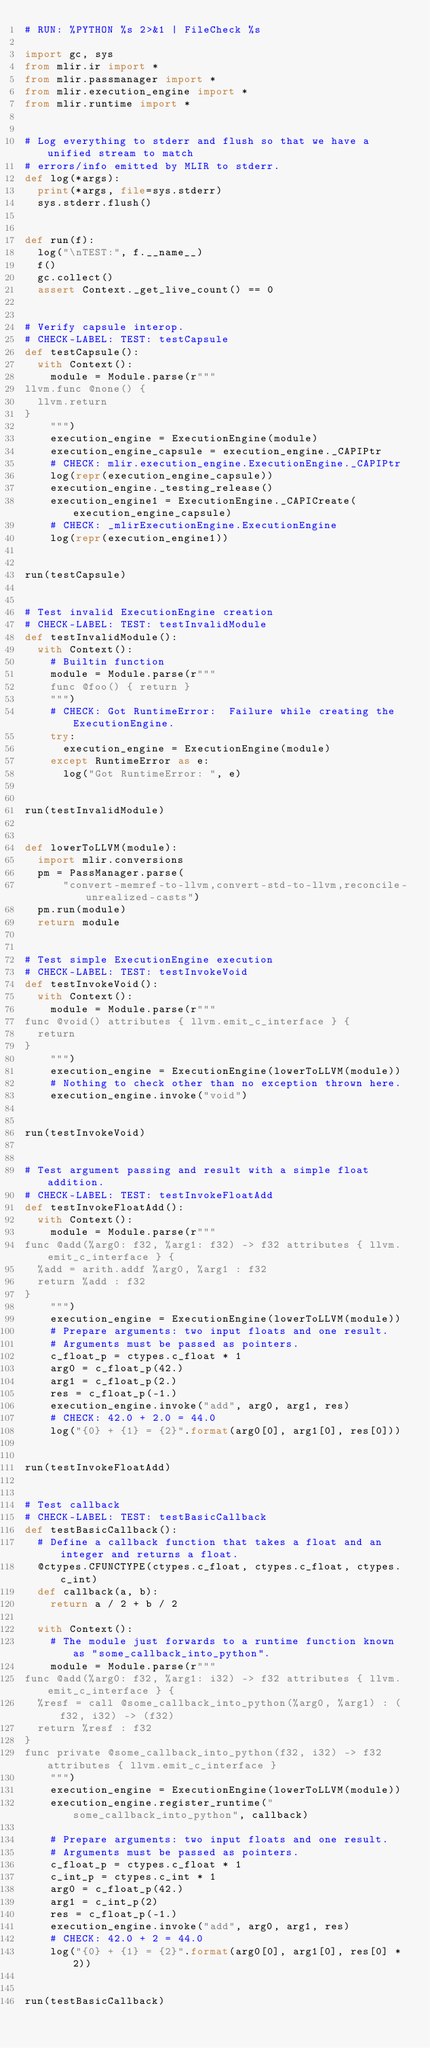Convert code to text. <code><loc_0><loc_0><loc_500><loc_500><_Python_># RUN: %PYTHON %s 2>&1 | FileCheck %s

import gc, sys
from mlir.ir import *
from mlir.passmanager import *
from mlir.execution_engine import *
from mlir.runtime import *


# Log everything to stderr and flush so that we have a unified stream to match
# errors/info emitted by MLIR to stderr.
def log(*args):
  print(*args, file=sys.stderr)
  sys.stderr.flush()


def run(f):
  log("\nTEST:", f.__name__)
  f()
  gc.collect()
  assert Context._get_live_count() == 0


# Verify capsule interop.
# CHECK-LABEL: TEST: testCapsule
def testCapsule():
  with Context():
    module = Module.parse(r"""
llvm.func @none() {
  llvm.return
}
    """)
    execution_engine = ExecutionEngine(module)
    execution_engine_capsule = execution_engine._CAPIPtr
    # CHECK: mlir.execution_engine.ExecutionEngine._CAPIPtr
    log(repr(execution_engine_capsule))
    execution_engine._testing_release()
    execution_engine1 = ExecutionEngine._CAPICreate(execution_engine_capsule)
    # CHECK: _mlirExecutionEngine.ExecutionEngine
    log(repr(execution_engine1))


run(testCapsule)


# Test invalid ExecutionEngine creation
# CHECK-LABEL: TEST: testInvalidModule
def testInvalidModule():
  with Context():
    # Builtin function
    module = Module.parse(r"""
    func @foo() { return }
    """)
    # CHECK: Got RuntimeError:  Failure while creating the ExecutionEngine.
    try:
      execution_engine = ExecutionEngine(module)
    except RuntimeError as e:
      log("Got RuntimeError: ", e)


run(testInvalidModule)


def lowerToLLVM(module):
  import mlir.conversions
  pm = PassManager.parse(
      "convert-memref-to-llvm,convert-std-to-llvm,reconcile-unrealized-casts")
  pm.run(module)
  return module


# Test simple ExecutionEngine execution
# CHECK-LABEL: TEST: testInvokeVoid
def testInvokeVoid():
  with Context():
    module = Module.parse(r"""
func @void() attributes { llvm.emit_c_interface } {
  return
}
    """)
    execution_engine = ExecutionEngine(lowerToLLVM(module))
    # Nothing to check other than no exception thrown here.
    execution_engine.invoke("void")


run(testInvokeVoid)


# Test argument passing and result with a simple float addition.
# CHECK-LABEL: TEST: testInvokeFloatAdd
def testInvokeFloatAdd():
  with Context():
    module = Module.parse(r"""
func @add(%arg0: f32, %arg1: f32) -> f32 attributes { llvm.emit_c_interface } {
  %add = arith.addf %arg0, %arg1 : f32
  return %add : f32
}
    """)
    execution_engine = ExecutionEngine(lowerToLLVM(module))
    # Prepare arguments: two input floats and one result.
    # Arguments must be passed as pointers.
    c_float_p = ctypes.c_float * 1
    arg0 = c_float_p(42.)
    arg1 = c_float_p(2.)
    res = c_float_p(-1.)
    execution_engine.invoke("add", arg0, arg1, res)
    # CHECK: 42.0 + 2.0 = 44.0
    log("{0} + {1} = {2}".format(arg0[0], arg1[0], res[0]))


run(testInvokeFloatAdd)


# Test callback
# CHECK-LABEL: TEST: testBasicCallback
def testBasicCallback():
  # Define a callback function that takes a float and an integer and returns a float.
  @ctypes.CFUNCTYPE(ctypes.c_float, ctypes.c_float, ctypes.c_int)
  def callback(a, b):
    return a / 2 + b / 2

  with Context():
    # The module just forwards to a runtime function known as "some_callback_into_python".
    module = Module.parse(r"""
func @add(%arg0: f32, %arg1: i32) -> f32 attributes { llvm.emit_c_interface } {
  %resf = call @some_callback_into_python(%arg0, %arg1) : (f32, i32) -> (f32)
  return %resf : f32
}
func private @some_callback_into_python(f32, i32) -> f32 attributes { llvm.emit_c_interface }
    """)
    execution_engine = ExecutionEngine(lowerToLLVM(module))
    execution_engine.register_runtime("some_callback_into_python", callback)

    # Prepare arguments: two input floats and one result.
    # Arguments must be passed as pointers.
    c_float_p = ctypes.c_float * 1
    c_int_p = ctypes.c_int * 1
    arg0 = c_float_p(42.)
    arg1 = c_int_p(2)
    res = c_float_p(-1.)
    execution_engine.invoke("add", arg0, arg1, res)
    # CHECK: 42.0 + 2 = 44.0
    log("{0} + {1} = {2}".format(arg0[0], arg1[0], res[0] * 2))


run(testBasicCallback)

</code> 